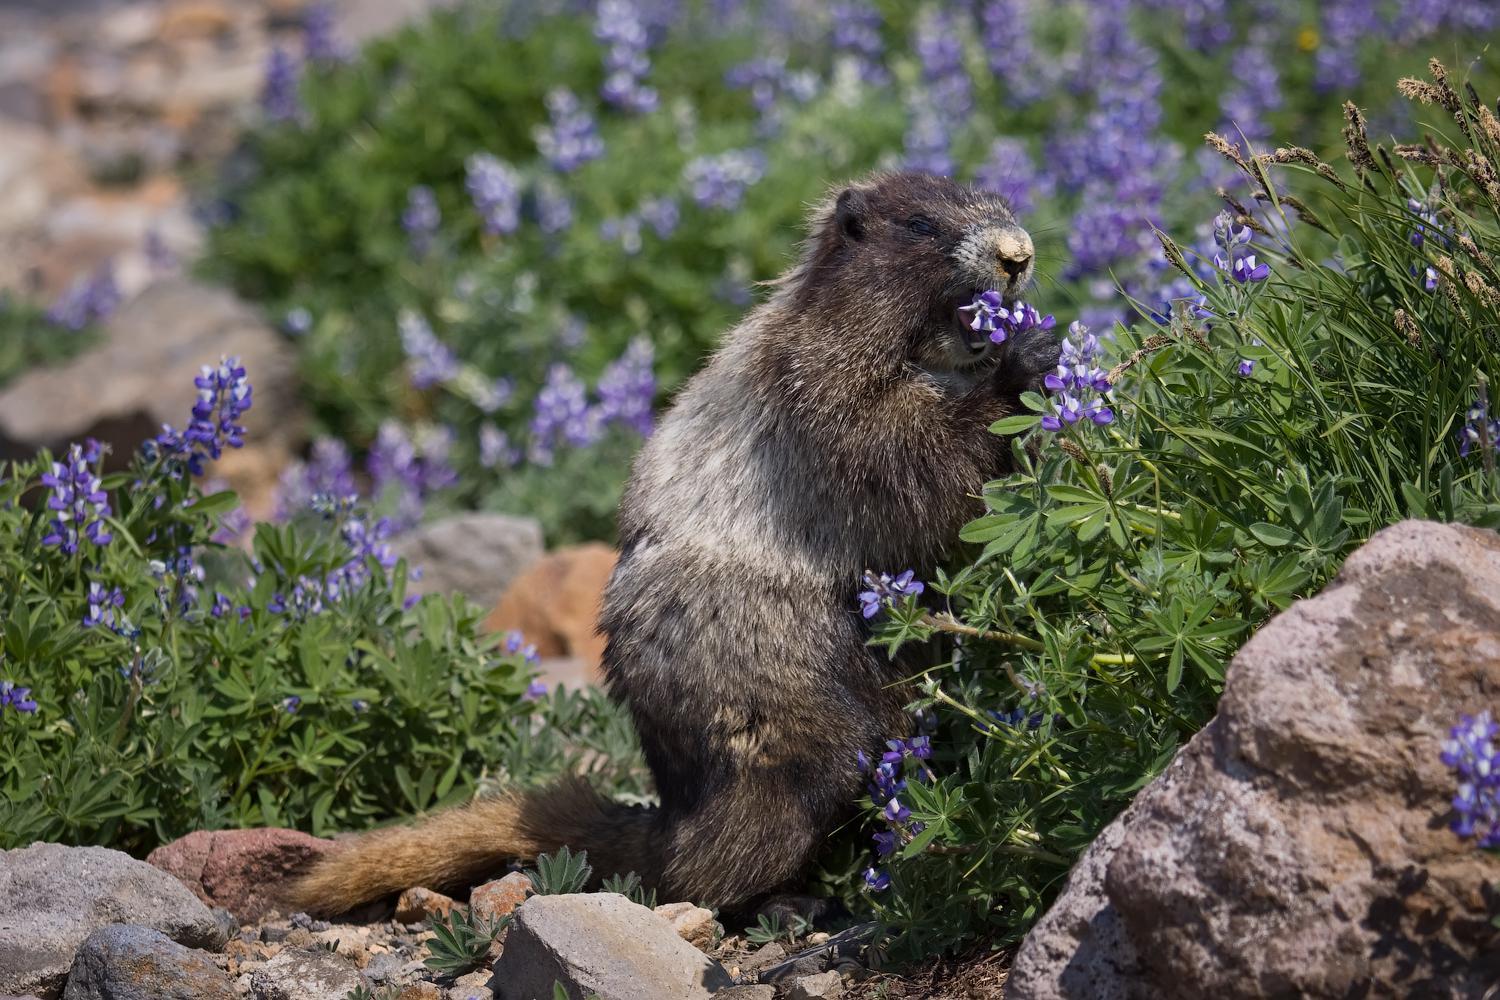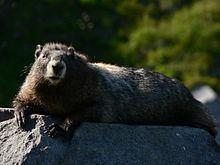The first image is the image on the left, the second image is the image on the right. Considering the images on both sides, is "There is 1 or more woodchucks facing right." valid? Answer yes or no. Yes. The first image is the image on the left, the second image is the image on the right. Analyze the images presented: Is the assertion "In one of the photos, the marmot's nose is near a blossom." valid? Answer yes or no. Yes. 